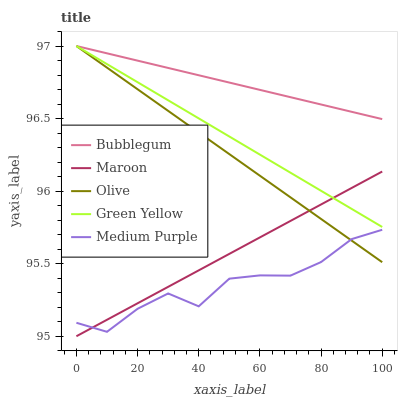Does Medium Purple have the minimum area under the curve?
Answer yes or no. Yes. Does Bubblegum have the maximum area under the curve?
Answer yes or no. Yes. Does Green Yellow have the minimum area under the curve?
Answer yes or no. No. Does Green Yellow have the maximum area under the curve?
Answer yes or no. No. Is Maroon the smoothest?
Answer yes or no. Yes. Is Medium Purple the roughest?
Answer yes or no. Yes. Is Green Yellow the smoothest?
Answer yes or no. No. Is Green Yellow the roughest?
Answer yes or no. No. Does Medium Purple have the lowest value?
Answer yes or no. No. Does Medium Purple have the highest value?
Answer yes or no. No. Is Maroon less than Bubblegum?
Answer yes or no. Yes. Is Bubblegum greater than Maroon?
Answer yes or no. Yes. Does Maroon intersect Bubblegum?
Answer yes or no. No. 